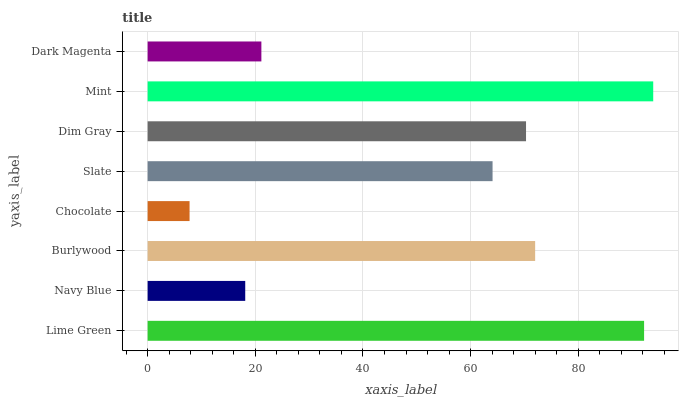Is Chocolate the minimum?
Answer yes or no. Yes. Is Mint the maximum?
Answer yes or no. Yes. Is Navy Blue the minimum?
Answer yes or no. No. Is Navy Blue the maximum?
Answer yes or no. No. Is Lime Green greater than Navy Blue?
Answer yes or no. Yes. Is Navy Blue less than Lime Green?
Answer yes or no. Yes. Is Navy Blue greater than Lime Green?
Answer yes or no. No. Is Lime Green less than Navy Blue?
Answer yes or no. No. Is Dim Gray the high median?
Answer yes or no. Yes. Is Slate the low median?
Answer yes or no. Yes. Is Burlywood the high median?
Answer yes or no. No. Is Mint the low median?
Answer yes or no. No. 